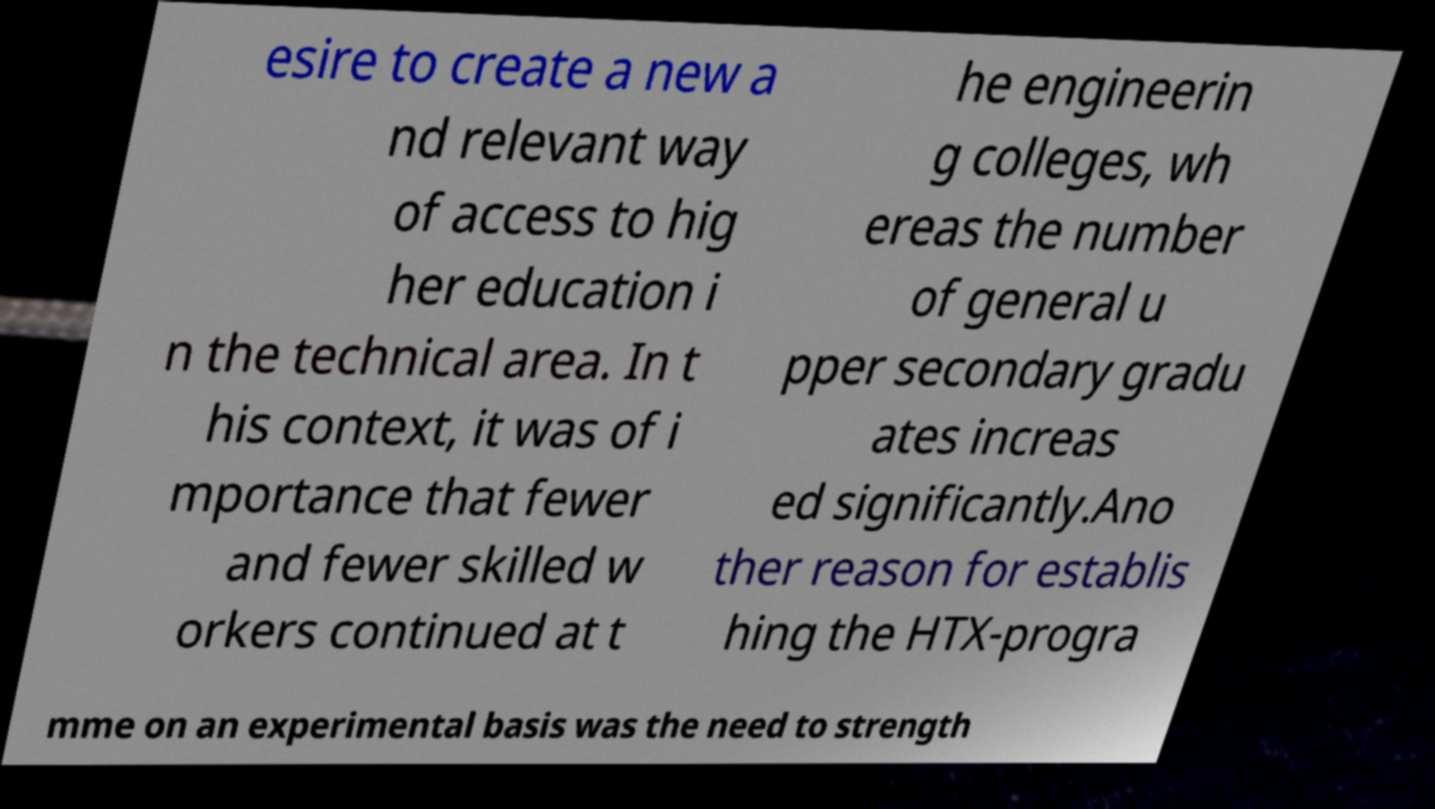What messages or text are displayed in this image? I need them in a readable, typed format. esire to create a new a nd relevant way of access to hig her education i n the technical area. In t his context, it was of i mportance that fewer and fewer skilled w orkers continued at t he engineerin g colleges, wh ereas the number of general u pper secondary gradu ates increas ed significantly.Ano ther reason for establis hing the HTX-progra mme on an experimental basis was the need to strength 